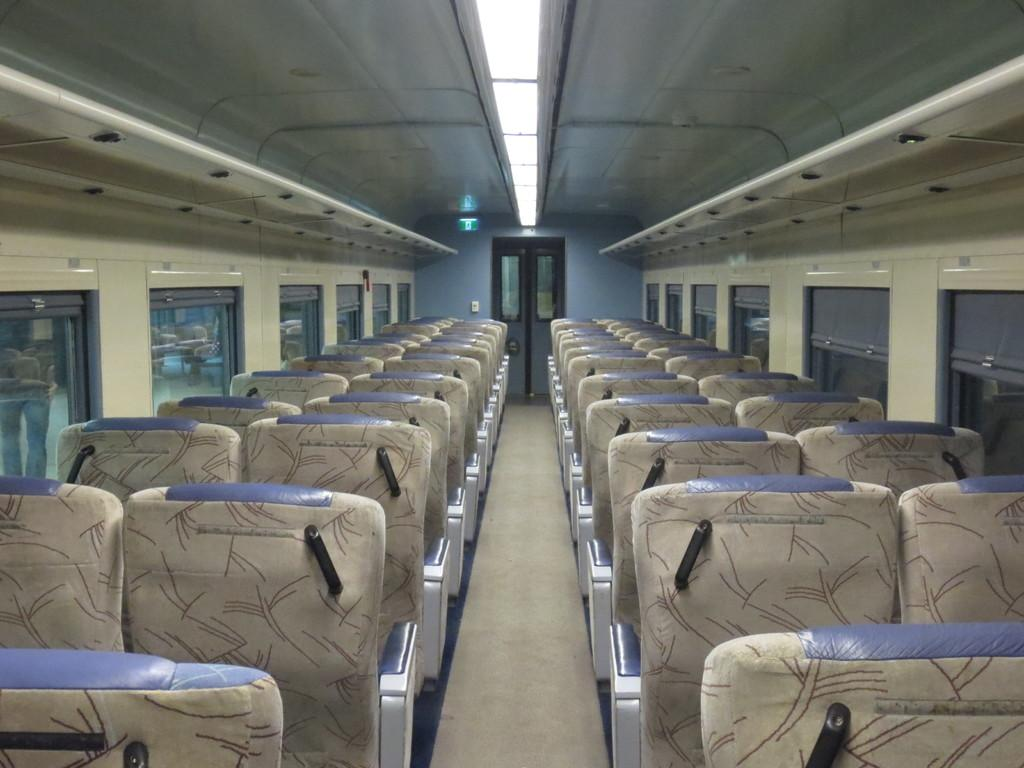What is the condition of the seats in the image? The seats in the image are empty. What can be seen at the top of the image? There are lights visible at the top of the image. What is the approval rating of the tub in the image? There is no tub present in the image, so it is not possible to determine an approval rating. 